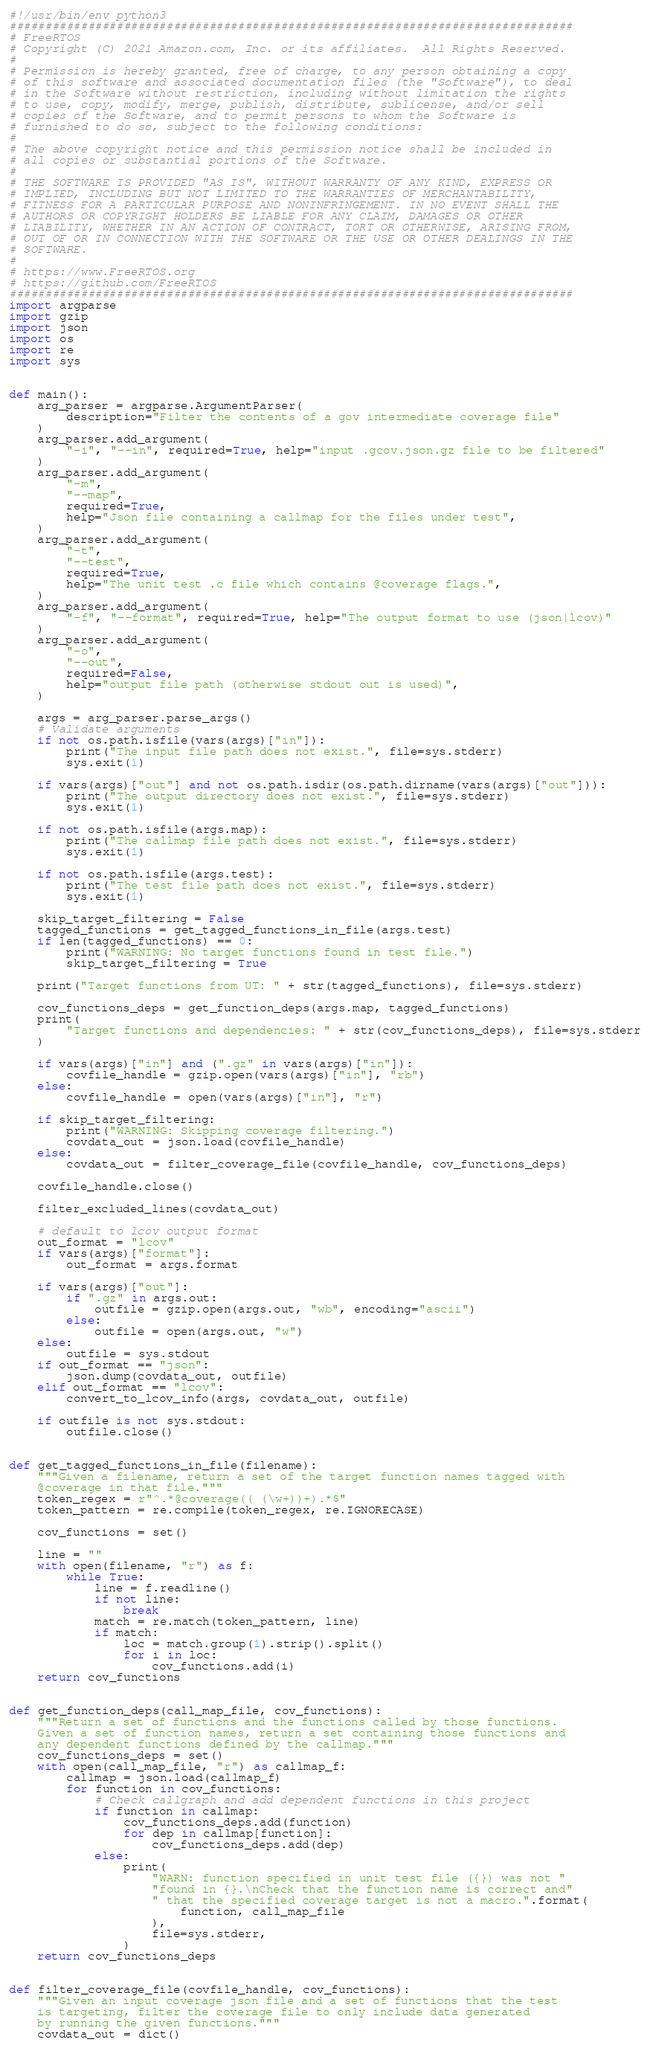Convert code to text. <code><loc_0><loc_0><loc_500><loc_500><_Python_>#!/usr/bin/env python3
###############################################################################
# FreeRTOS
# Copyright (C) 2021 Amazon.com, Inc. or its affiliates.  All Rights Reserved.
#
# Permission is hereby granted, free of charge, to any person obtaining a copy
# of this software and associated documentation files (the "Software"), to deal
# in the Software without restriction, including without limitation the rights
# to use, copy, modify, merge, publish, distribute, sublicense, and/or sell
# copies of the Software, and to permit persons to whom the Software is
# furnished to do so, subject to the following conditions:
#
# The above copyright notice and this permission notice shall be included in
# all copies or substantial portions of the Software.
#
# THE SOFTWARE IS PROVIDED "AS IS", WITHOUT WARRANTY OF ANY KIND, EXPRESS OR
# IMPLIED, INCLUDING BUT NOT LIMITED TO THE WARRANTIES OF MERCHANTABILITY,
# FITNESS FOR A PARTICULAR PURPOSE AND NONINFRINGEMENT. IN NO EVENT SHALL THE
# AUTHORS OR COPYRIGHT HOLDERS BE LIABLE FOR ANY CLAIM, DAMAGES OR OTHER
# LIABILITY, WHETHER IN AN ACTION OF CONTRACT, TORT OR OTHERWISE, ARISING FROM,
# OUT OF OR IN CONNECTION WITH THE SOFTWARE OR THE USE OR OTHER DEALINGS IN THE
# SOFTWARE.
#
# https://www.FreeRTOS.org
# https://github.com/FreeRTOS
###############################################################################
import argparse
import gzip
import json
import os
import re
import sys


def main():
    arg_parser = argparse.ArgumentParser(
        description="Filter the contents of a gov intermediate coverage file"
    )
    arg_parser.add_argument(
        "-i", "--in", required=True, help="input .gcov.json.gz file to be filtered"
    )
    arg_parser.add_argument(
        "-m",
        "--map",
        required=True,
        help="Json file containing a callmap for the files under test",
    )
    arg_parser.add_argument(
        "-t",
        "--test",
        required=True,
        help="The unit test .c file which contains @coverage flags.",
    )
    arg_parser.add_argument(
        "-f", "--format", required=True, help="The output format to use (json|lcov)"
    )
    arg_parser.add_argument(
        "-o",
        "--out",
        required=False,
        help="output file path (otherwise stdout out is used)",
    )

    args = arg_parser.parse_args()
    # Validate arguments
    if not os.path.isfile(vars(args)["in"]):
        print("The input file path does not exist.", file=sys.stderr)
        sys.exit(1)

    if vars(args)["out"] and not os.path.isdir(os.path.dirname(vars(args)["out"])):
        print("The output directory does not exist.", file=sys.stderr)
        sys.exit(1)

    if not os.path.isfile(args.map):
        print("The callmap file path does not exist.", file=sys.stderr)
        sys.exit(1)

    if not os.path.isfile(args.test):
        print("The test file path does not exist.", file=sys.stderr)
        sys.exit(1)

    skip_target_filtering = False
    tagged_functions = get_tagged_functions_in_file(args.test)
    if len(tagged_functions) == 0:
        print("WARNING: No target functions found in test file.")
        skip_target_filtering = True

    print("Target functions from UT: " + str(tagged_functions), file=sys.stderr)

    cov_functions_deps = get_function_deps(args.map, tagged_functions)
    print(
        "Target functions and dependencies: " + str(cov_functions_deps), file=sys.stderr
    )

    if vars(args)["in"] and (".gz" in vars(args)["in"]):
        covfile_handle = gzip.open(vars(args)["in"], "rb")
    else:
        covfile_handle = open(vars(args)["in"], "r")

    if skip_target_filtering:
        print("WARNING: Skipping coverage filtering.")
        covdata_out = json.load(covfile_handle)
    else:
        covdata_out = filter_coverage_file(covfile_handle, cov_functions_deps)

    covfile_handle.close()

    filter_excluded_lines(covdata_out)

    # default to lcov output format
    out_format = "lcov"
    if vars(args)["format"]:
        out_format = args.format

    if vars(args)["out"]:
        if ".gz" in args.out:
            outfile = gzip.open(args.out, "wb", encoding="ascii")
        else:
            outfile = open(args.out, "w")
    else:
        outfile = sys.stdout
    if out_format == "json":
        json.dump(covdata_out, outfile)
    elif out_format == "lcov":
        convert_to_lcov_info(args, covdata_out, outfile)

    if outfile is not sys.stdout:
        outfile.close()


def get_tagged_functions_in_file(filename):
    """Given a filename, return a set of the target function names tagged with
    @coverage in that file."""
    token_regex = r"^.*@coverage(( (\w+))+).*$"
    token_pattern = re.compile(token_regex, re.IGNORECASE)

    cov_functions = set()

    line = ""
    with open(filename, "r") as f:
        while True:
            line = f.readline()
            if not line:
                break
            match = re.match(token_pattern, line)
            if match:
                loc = match.group(1).strip().split()
                for i in loc:
                    cov_functions.add(i)
    return cov_functions


def get_function_deps(call_map_file, cov_functions):
    """Return a set of functions and the functions called by those functions.
    Given a set of function names, return a set containing those functions and
    any dependent functions defined by the callmap."""
    cov_functions_deps = set()
    with open(call_map_file, "r") as callmap_f:
        callmap = json.load(callmap_f)
        for function in cov_functions:
            # Check callgraph and add dependent functions in this project
            if function in callmap:
                cov_functions_deps.add(function)
                for dep in callmap[function]:
                    cov_functions_deps.add(dep)
            else:
                print(
                    "WARN: function specified in unit test file ({}) was not "
                    "found in {}.\nCheck that the function name is correct and"
                    " that the specified coverage target is not a macro.".format(
                        function, call_map_file
                    ),
                    file=sys.stderr,
                )
    return cov_functions_deps


def filter_coverage_file(covfile_handle, cov_functions):
    """Given an input coverage json file and a set of functions that the test
    is targeting, filter the coverage file to only include data generated
    by running the given functions."""
    covdata_out = dict()</code> 